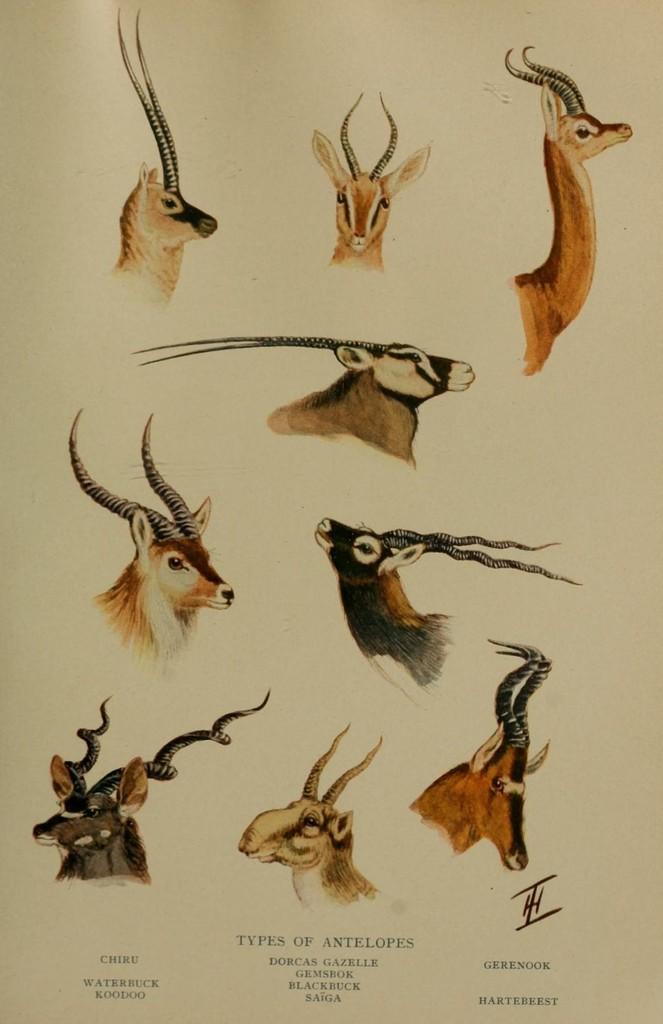Please provide a concise description of this image. In this image we can see a paper and on the paper we can see the different types of antelopes. At the bottom we can see the text. 